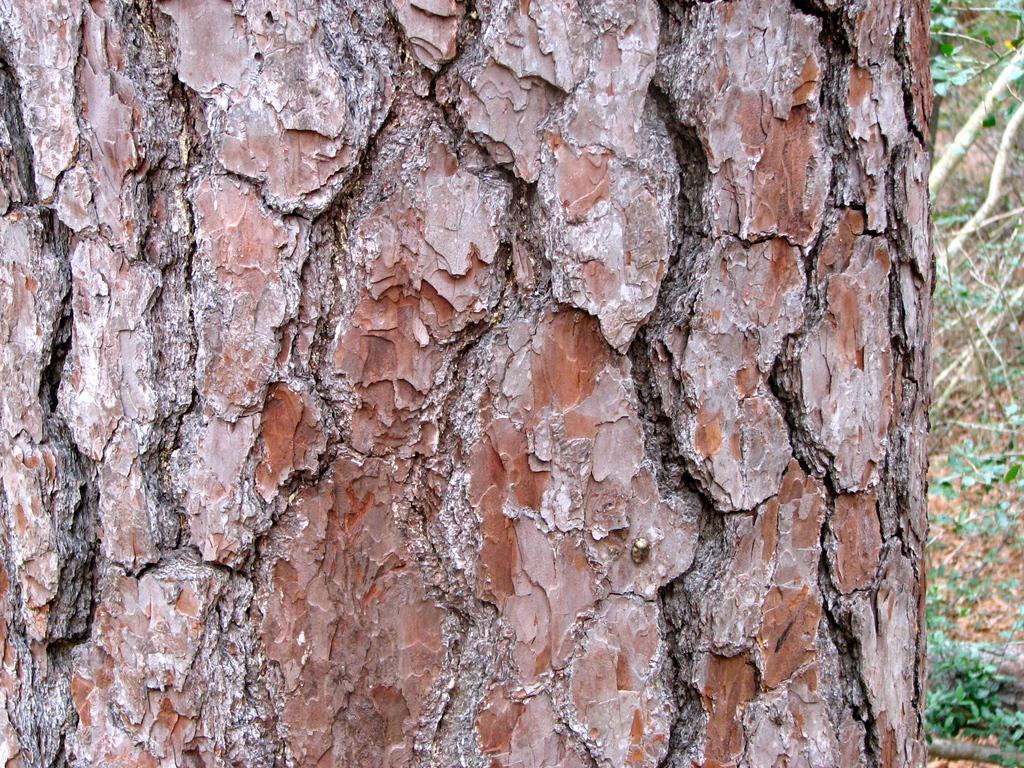Could you give a brief overview of what you see in this image? In this image I can see trunk which is in brown color. Background I can see trees in green color. 